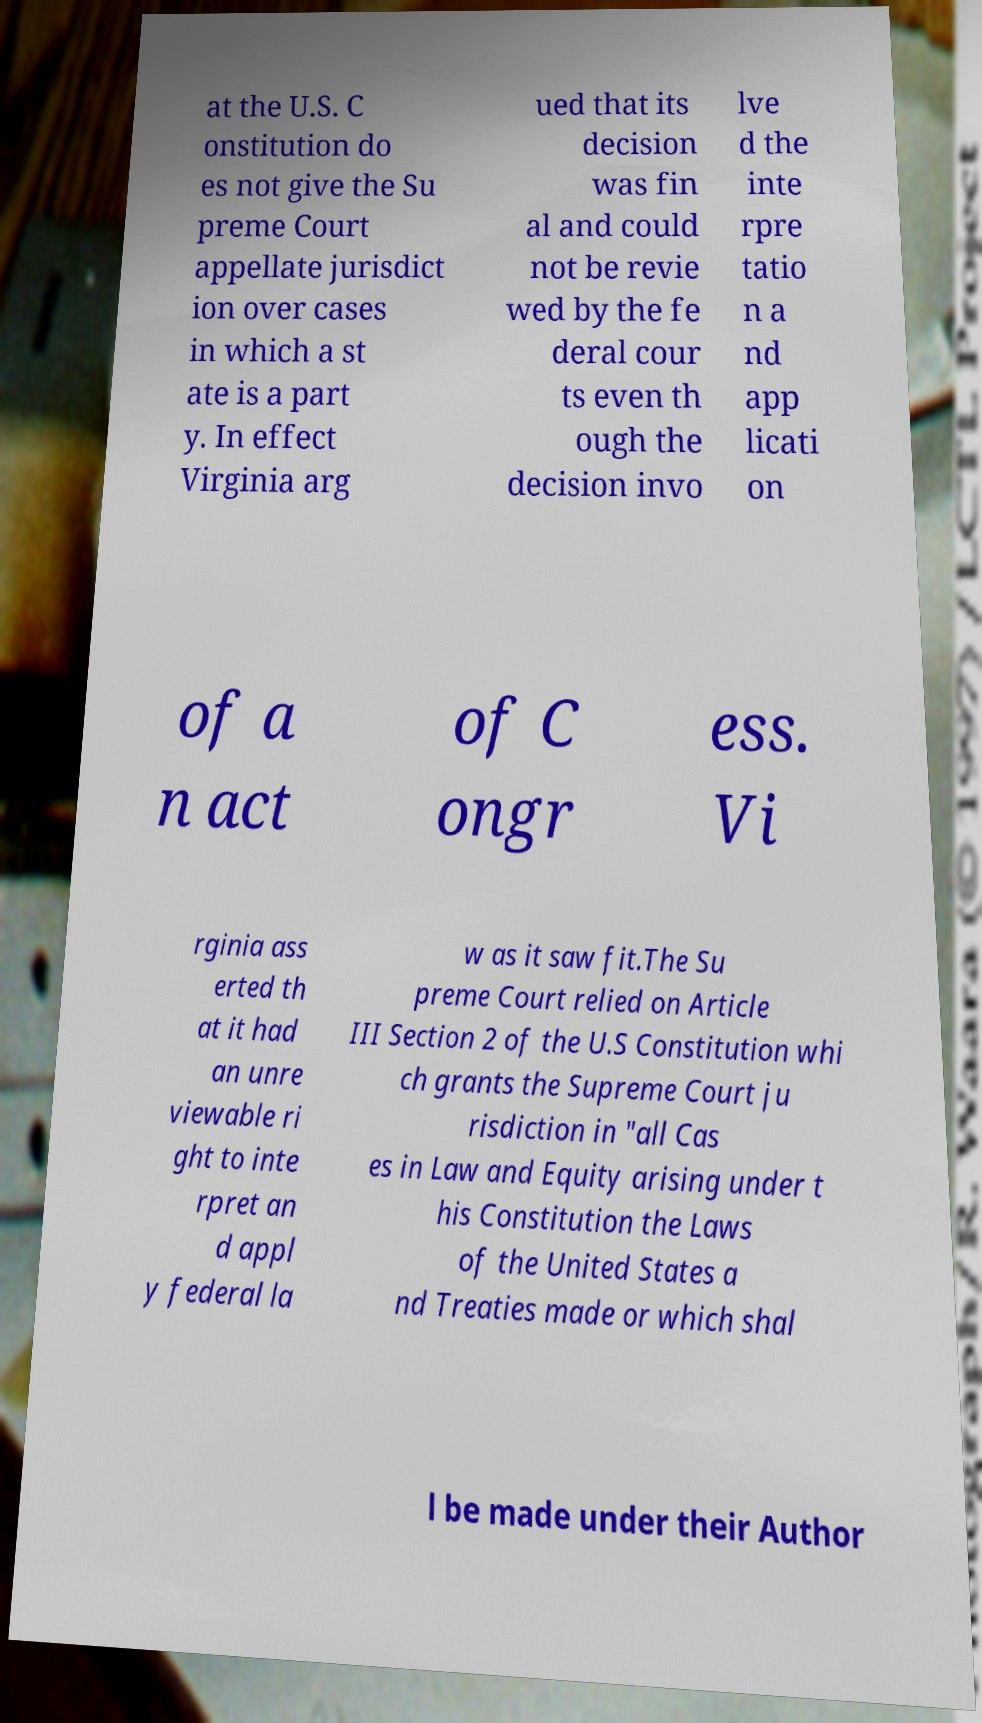Could you assist in decoding the text presented in this image and type it out clearly? at the U.S. C onstitution do es not give the Su preme Court appellate jurisdict ion over cases in which a st ate is a part y. In effect Virginia arg ued that its decision was fin al and could not be revie wed by the fe deral cour ts even th ough the decision invo lve d the inte rpre tatio n a nd app licati on of a n act of C ongr ess. Vi rginia ass erted th at it had an unre viewable ri ght to inte rpret an d appl y federal la w as it saw fit.The Su preme Court relied on Article III Section 2 of the U.S Constitution whi ch grants the Supreme Court ju risdiction in "all Cas es in Law and Equity arising under t his Constitution the Laws of the United States a nd Treaties made or which shal l be made under their Author 